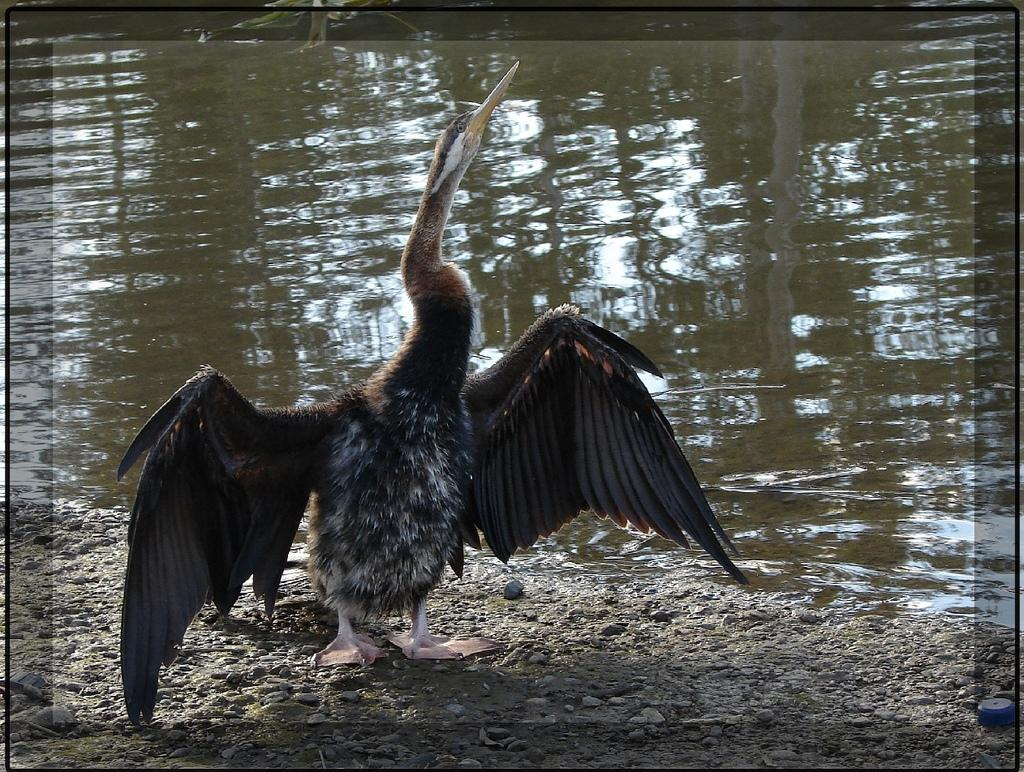What type of animal is on the ground in the image? There is a bird on the ground in the image. What can be seen in the background of the image? There is water visible in the background of the image. What type of milk is the bird drinking from the dock in the image? There is no dock or milk present in the image; it features a bird on the ground and water in the background. 